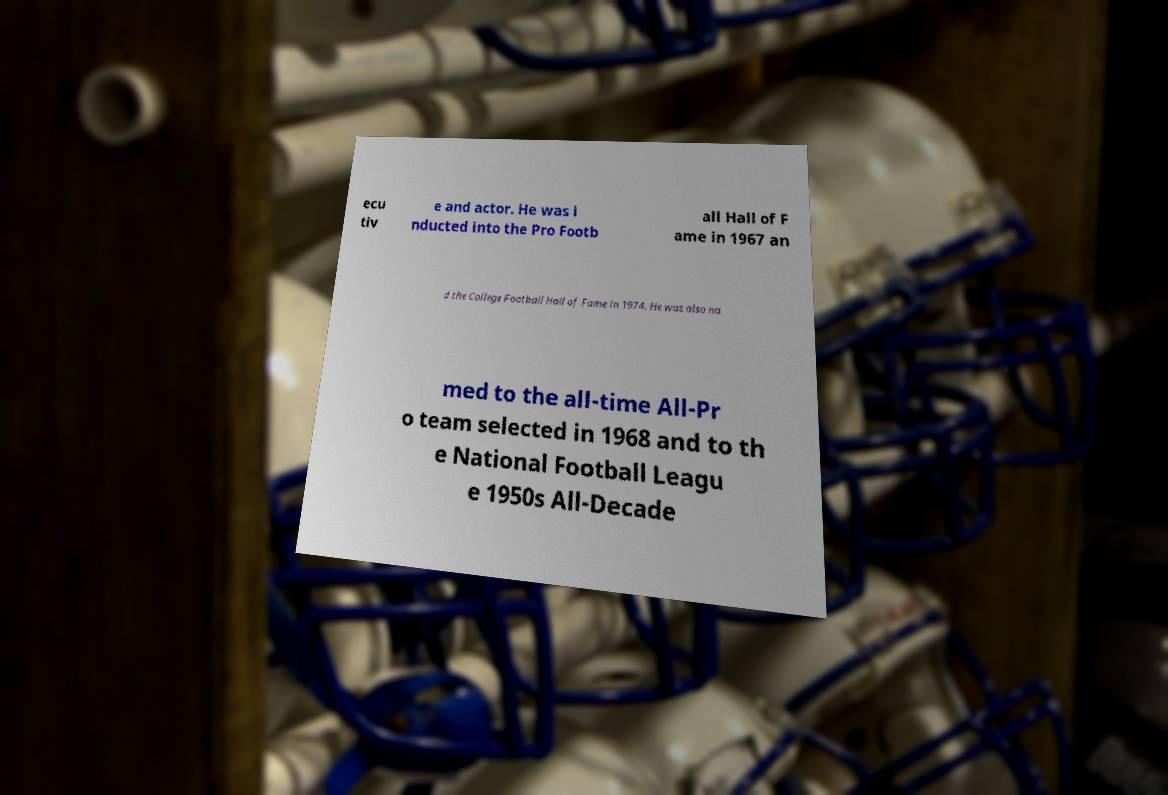Please read and relay the text visible in this image. What does it say? ecu tiv e and actor. He was i nducted into the Pro Footb all Hall of F ame in 1967 an d the College Football Hall of Fame in 1974. He was also na med to the all-time All-Pr o team selected in 1968 and to th e National Football Leagu e 1950s All-Decade 